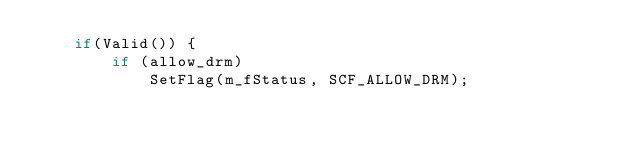Convert code to text. <code><loc_0><loc_0><loc_500><loc_500><_C++_>    if(Valid()) {
        if (allow_drm)
            SetFlag(m_fStatus, SCF_ALLOW_DRM);</code> 